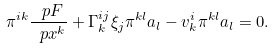Convert formula to latex. <formula><loc_0><loc_0><loc_500><loc_500>\pi ^ { i k } \frac { \ p F } { \ p x ^ { k } } + \Gamma ^ { i j } _ { k } \xi _ { j } \pi ^ { k l } a _ { l } - v ^ { i } _ { k } \pi ^ { k l } a _ { l } = 0 .</formula> 